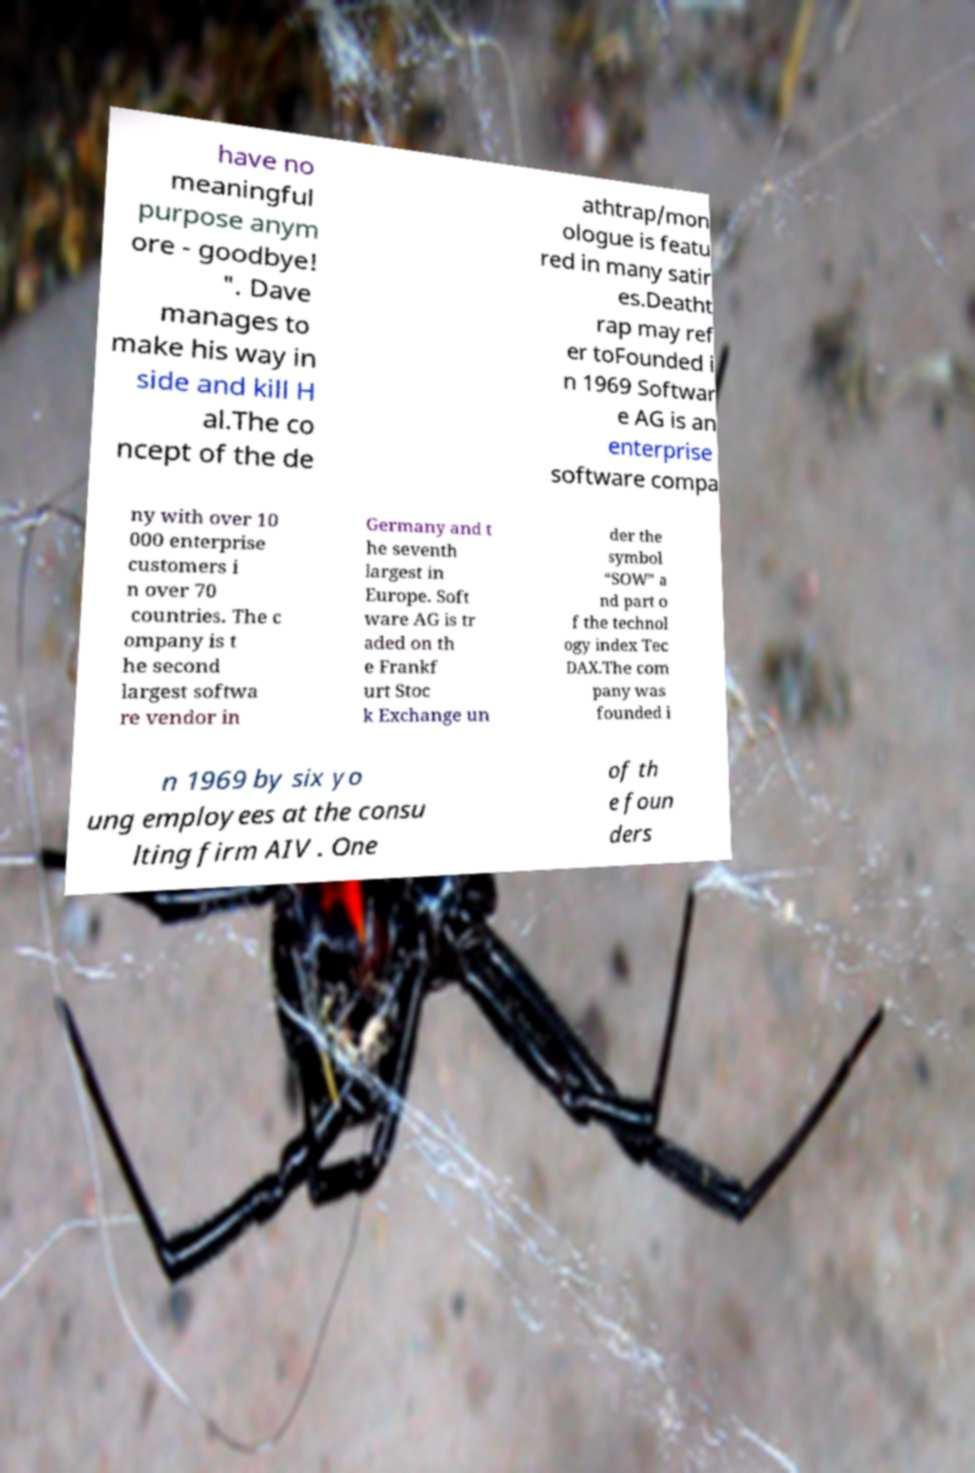There's text embedded in this image that I need extracted. Can you transcribe it verbatim? have no meaningful purpose anym ore - goodbye! ". Dave manages to make his way in side and kill H al.The co ncept of the de athtrap/mon ologue is featu red in many satir es.Deatht rap may ref er toFounded i n 1969 Softwar e AG is an enterprise software compa ny with over 10 000 enterprise customers i n over 70 countries. The c ompany is t he second largest softwa re vendor in Germany and t he seventh largest in Europe. Soft ware AG is tr aded on th e Frankf urt Stoc k Exchange un der the symbol “SOW” a nd part o f the technol ogy index Tec DAX.The com pany was founded i n 1969 by six yo ung employees at the consu lting firm AIV . One of th e foun ders 